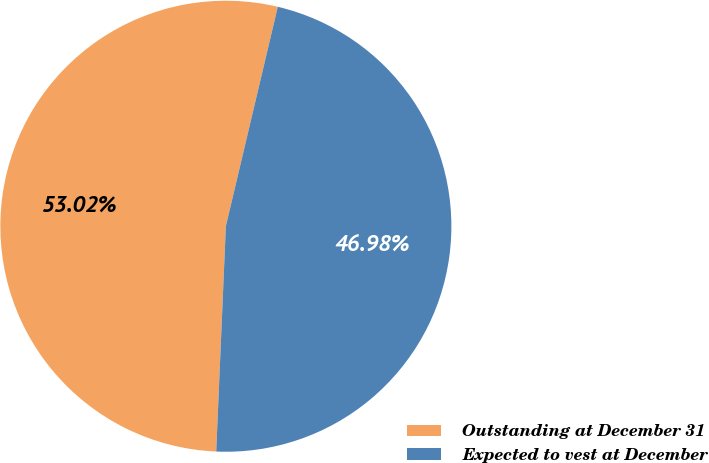Convert chart to OTSL. <chart><loc_0><loc_0><loc_500><loc_500><pie_chart><fcel>Outstanding at December 31<fcel>Expected to vest at December<nl><fcel>53.02%<fcel>46.98%<nl></chart> 